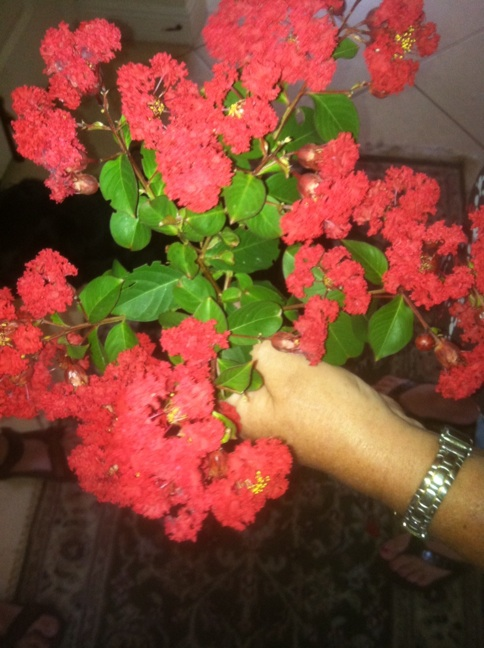What are the common uses of crape myrtles in landscaping? Crape myrtles are versatile in landscaping, used for their ornamental value in residential yards, public parks, and along streets. Their ability to form dense shrubs or small trees allows them to be implemented as focal points, hedges, or even privacy screens. Their long-lasting and colorful flowers add vibrant aesthetics to any setting. 